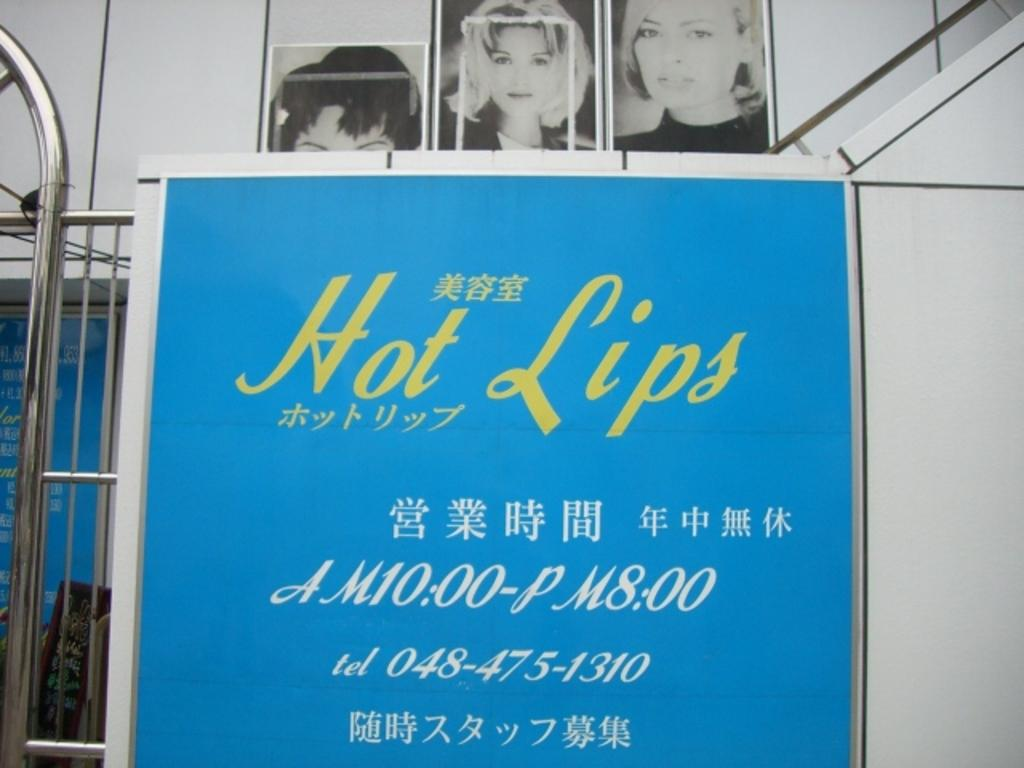What can be seen on the posters in the image? There are posters with information in the image. What type of structure is visible in the image? There is railing visible in the image. What can be seen in the background of the image? There are posts of people in the background of the image. What type of curtain is hanging in the image? There is no curtain present in the image. What kind of music can be heard in the background of the image? There is no music present in the image. 